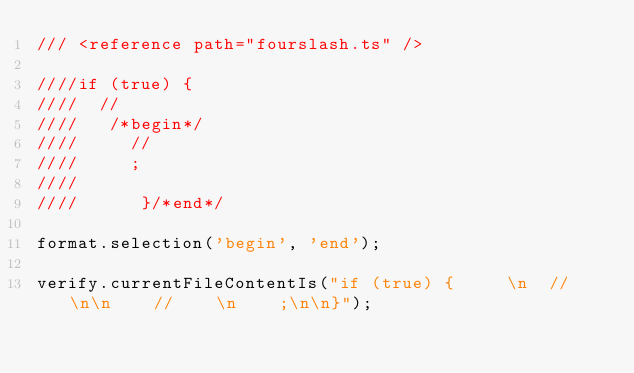Convert code to text. <code><loc_0><loc_0><loc_500><loc_500><_TypeScript_>/// <reference path="fourslash.ts" />

////if (true) {     
////  //   
////   /*begin*/   
////     //    
////     ;    
////       
////      }/*end*/

format.selection('begin', 'end');

verify.currentFileContentIs("if (true) {     \n  //   \n\n    //    \n    ;\n\n}");
</code> 